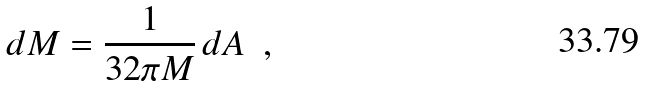<formula> <loc_0><loc_0><loc_500><loc_500>d M = \frac { 1 } { 3 2 \pi M } \, d A \ \ ,</formula> 